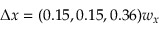<formula> <loc_0><loc_0><loc_500><loc_500>\Delta x = ( 0 . 1 5 , 0 . 1 5 , 0 . 3 6 ) w _ { x }</formula> 